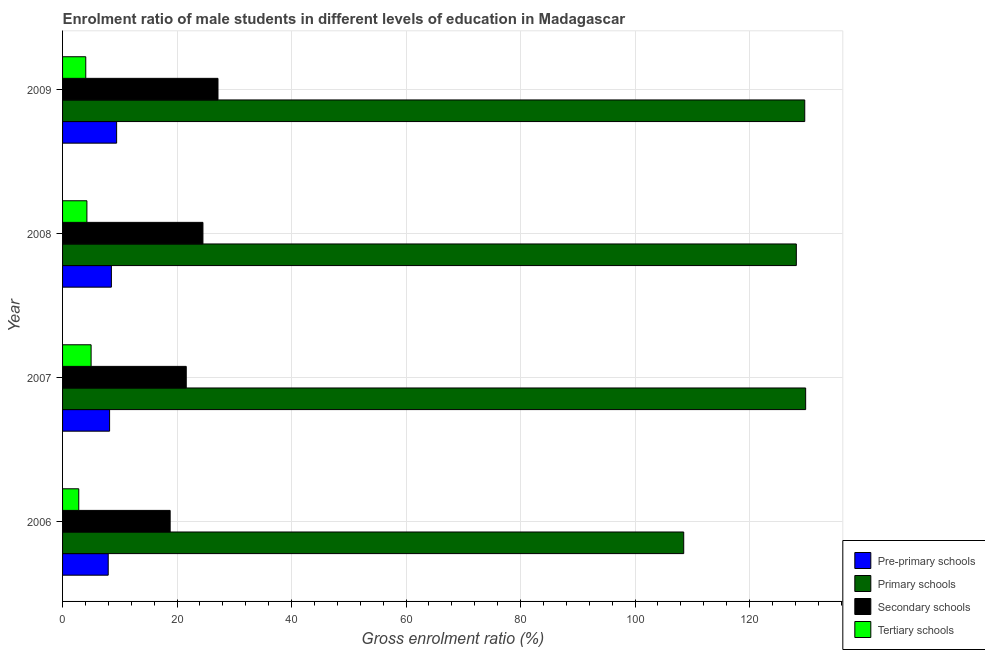Are the number of bars on each tick of the Y-axis equal?
Provide a succinct answer. Yes. How many bars are there on the 3rd tick from the top?
Your answer should be compact. 4. What is the label of the 4th group of bars from the top?
Provide a short and direct response. 2006. What is the gross enrolment ratio(female) in tertiary schools in 2007?
Give a very brief answer. 4.99. Across all years, what is the maximum gross enrolment ratio(female) in tertiary schools?
Make the answer very short. 4.99. Across all years, what is the minimum gross enrolment ratio(female) in primary schools?
Give a very brief answer. 108.5. In which year was the gross enrolment ratio(female) in pre-primary schools minimum?
Give a very brief answer. 2006. What is the total gross enrolment ratio(female) in pre-primary schools in the graph?
Make the answer very short. 34.16. What is the difference between the gross enrolment ratio(female) in tertiary schools in 2007 and that in 2009?
Keep it short and to the point. 0.93. What is the difference between the gross enrolment ratio(female) in pre-primary schools in 2007 and the gross enrolment ratio(female) in secondary schools in 2006?
Provide a succinct answer. -10.58. What is the average gross enrolment ratio(female) in pre-primary schools per year?
Give a very brief answer. 8.54. In the year 2008, what is the difference between the gross enrolment ratio(female) in primary schools and gross enrolment ratio(female) in tertiary schools?
Your response must be concise. 123.92. What is the ratio of the gross enrolment ratio(female) in tertiary schools in 2007 to that in 2008?
Ensure brevity in your answer.  1.17. Is the difference between the gross enrolment ratio(female) in secondary schools in 2006 and 2009 greater than the difference between the gross enrolment ratio(female) in primary schools in 2006 and 2009?
Offer a terse response. Yes. What is the difference between the highest and the second highest gross enrolment ratio(female) in pre-primary schools?
Your response must be concise. 0.91. What is the difference between the highest and the lowest gross enrolment ratio(female) in pre-primary schools?
Your answer should be very brief. 1.47. Is the sum of the gross enrolment ratio(female) in secondary schools in 2006 and 2008 greater than the maximum gross enrolment ratio(female) in tertiary schools across all years?
Your answer should be compact. Yes. What does the 1st bar from the top in 2007 represents?
Offer a very short reply. Tertiary schools. What does the 4th bar from the bottom in 2007 represents?
Your response must be concise. Tertiary schools. Is it the case that in every year, the sum of the gross enrolment ratio(female) in pre-primary schools and gross enrolment ratio(female) in primary schools is greater than the gross enrolment ratio(female) in secondary schools?
Provide a succinct answer. Yes. Are all the bars in the graph horizontal?
Offer a terse response. Yes. How many years are there in the graph?
Offer a terse response. 4. Are the values on the major ticks of X-axis written in scientific E-notation?
Give a very brief answer. No. Does the graph contain grids?
Your answer should be very brief. Yes. Where does the legend appear in the graph?
Offer a terse response. Bottom right. How many legend labels are there?
Your answer should be compact. 4. How are the legend labels stacked?
Offer a terse response. Vertical. What is the title of the graph?
Provide a short and direct response. Enrolment ratio of male students in different levels of education in Madagascar. What is the label or title of the X-axis?
Provide a succinct answer. Gross enrolment ratio (%). What is the Gross enrolment ratio (%) of Pre-primary schools in 2006?
Offer a very short reply. 7.97. What is the Gross enrolment ratio (%) of Primary schools in 2006?
Offer a very short reply. 108.5. What is the Gross enrolment ratio (%) in Secondary schools in 2006?
Provide a short and direct response. 18.79. What is the Gross enrolment ratio (%) of Tertiary schools in 2006?
Offer a terse response. 2.83. What is the Gross enrolment ratio (%) in Pre-primary schools in 2007?
Give a very brief answer. 8.21. What is the Gross enrolment ratio (%) in Primary schools in 2007?
Give a very brief answer. 129.8. What is the Gross enrolment ratio (%) of Secondary schools in 2007?
Offer a terse response. 21.61. What is the Gross enrolment ratio (%) of Tertiary schools in 2007?
Ensure brevity in your answer.  4.99. What is the Gross enrolment ratio (%) of Pre-primary schools in 2008?
Offer a very short reply. 8.53. What is the Gross enrolment ratio (%) of Primary schools in 2008?
Make the answer very short. 128.17. What is the Gross enrolment ratio (%) in Secondary schools in 2008?
Ensure brevity in your answer.  24.52. What is the Gross enrolment ratio (%) of Tertiary schools in 2008?
Your answer should be compact. 4.25. What is the Gross enrolment ratio (%) of Pre-primary schools in 2009?
Provide a short and direct response. 9.44. What is the Gross enrolment ratio (%) of Primary schools in 2009?
Offer a very short reply. 129.64. What is the Gross enrolment ratio (%) in Secondary schools in 2009?
Provide a short and direct response. 27.15. What is the Gross enrolment ratio (%) of Tertiary schools in 2009?
Ensure brevity in your answer.  4.05. Across all years, what is the maximum Gross enrolment ratio (%) of Pre-primary schools?
Offer a very short reply. 9.44. Across all years, what is the maximum Gross enrolment ratio (%) in Primary schools?
Provide a succinct answer. 129.8. Across all years, what is the maximum Gross enrolment ratio (%) in Secondary schools?
Your answer should be compact. 27.15. Across all years, what is the maximum Gross enrolment ratio (%) of Tertiary schools?
Your response must be concise. 4.99. Across all years, what is the minimum Gross enrolment ratio (%) in Pre-primary schools?
Your answer should be very brief. 7.97. Across all years, what is the minimum Gross enrolment ratio (%) in Primary schools?
Ensure brevity in your answer.  108.5. Across all years, what is the minimum Gross enrolment ratio (%) in Secondary schools?
Offer a terse response. 18.79. Across all years, what is the minimum Gross enrolment ratio (%) in Tertiary schools?
Your response must be concise. 2.83. What is the total Gross enrolment ratio (%) of Pre-primary schools in the graph?
Give a very brief answer. 34.16. What is the total Gross enrolment ratio (%) of Primary schools in the graph?
Offer a terse response. 496.12. What is the total Gross enrolment ratio (%) in Secondary schools in the graph?
Keep it short and to the point. 92.07. What is the total Gross enrolment ratio (%) of Tertiary schools in the graph?
Offer a very short reply. 16.12. What is the difference between the Gross enrolment ratio (%) in Pre-primary schools in 2006 and that in 2007?
Provide a succinct answer. -0.24. What is the difference between the Gross enrolment ratio (%) of Primary schools in 2006 and that in 2007?
Provide a succinct answer. -21.3. What is the difference between the Gross enrolment ratio (%) in Secondary schools in 2006 and that in 2007?
Your answer should be very brief. -2.81. What is the difference between the Gross enrolment ratio (%) of Tertiary schools in 2006 and that in 2007?
Provide a short and direct response. -2.16. What is the difference between the Gross enrolment ratio (%) in Pre-primary schools in 2006 and that in 2008?
Offer a very short reply. -0.55. What is the difference between the Gross enrolment ratio (%) in Primary schools in 2006 and that in 2008?
Offer a terse response. -19.67. What is the difference between the Gross enrolment ratio (%) of Secondary schools in 2006 and that in 2008?
Keep it short and to the point. -5.73. What is the difference between the Gross enrolment ratio (%) in Tertiary schools in 2006 and that in 2008?
Make the answer very short. -1.42. What is the difference between the Gross enrolment ratio (%) of Pre-primary schools in 2006 and that in 2009?
Give a very brief answer. -1.47. What is the difference between the Gross enrolment ratio (%) in Primary schools in 2006 and that in 2009?
Provide a short and direct response. -21.14. What is the difference between the Gross enrolment ratio (%) of Secondary schools in 2006 and that in 2009?
Ensure brevity in your answer.  -8.36. What is the difference between the Gross enrolment ratio (%) of Tertiary schools in 2006 and that in 2009?
Ensure brevity in your answer.  -1.22. What is the difference between the Gross enrolment ratio (%) in Pre-primary schools in 2007 and that in 2008?
Give a very brief answer. -0.31. What is the difference between the Gross enrolment ratio (%) in Primary schools in 2007 and that in 2008?
Keep it short and to the point. 1.63. What is the difference between the Gross enrolment ratio (%) of Secondary schools in 2007 and that in 2008?
Your response must be concise. -2.91. What is the difference between the Gross enrolment ratio (%) in Tertiary schools in 2007 and that in 2008?
Ensure brevity in your answer.  0.73. What is the difference between the Gross enrolment ratio (%) in Pre-primary schools in 2007 and that in 2009?
Your answer should be compact. -1.23. What is the difference between the Gross enrolment ratio (%) in Primary schools in 2007 and that in 2009?
Provide a short and direct response. 0.16. What is the difference between the Gross enrolment ratio (%) of Secondary schools in 2007 and that in 2009?
Ensure brevity in your answer.  -5.54. What is the difference between the Gross enrolment ratio (%) of Tertiary schools in 2007 and that in 2009?
Keep it short and to the point. 0.93. What is the difference between the Gross enrolment ratio (%) of Pre-primary schools in 2008 and that in 2009?
Give a very brief answer. -0.91. What is the difference between the Gross enrolment ratio (%) of Primary schools in 2008 and that in 2009?
Offer a terse response. -1.47. What is the difference between the Gross enrolment ratio (%) of Secondary schools in 2008 and that in 2009?
Provide a short and direct response. -2.63. What is the difference between the Gross enrolment ratio (%) of Tertiary schools in 2008 and that in 2009?
Provide a succinct answer. 0.2. What is the difference between the Gross enrolment ratio (%) in Pre-primary schools in 2006 and the Gross enrolment ratio (%) in Primary schools in 2007?
Make the answer very short. -121.83. What is the difference between the Gross enrolment ratio (%) of Pre-primary schools in 2006 and the Gross enrolment ratio (%) of Secondary schools in 2007?
Give a very brief answer. -13.63. What is the difference between the Gross enrolment ratio (%) in Pre-primary schools in 2006 and the Gross enrolment ratio (%) in Tertiary schools in 2007?
Offer a terse response. 2.99. What is the difference between the Gross enrolment ratio (%) of Primary schools in 2006 and the Gross enrolment ratio (%) of Secondary schools in 2007?
Ensure brevity in your answer.  86.9. What is the difference between the Gross enrolment ratio (%) in Primary schools in 2006 and the Gross enrolment ratio (%) in Tertiary schools in 2007?
Keep it short and to the point. 103.52. What is the difference between the Gross enrolment ratio (%) in Secondary schools in 2006 and the Gross enrolment ratio (%) in Tertiary schools in 2007?
Your answer should be very brief. 13.81. What is the difference between the Gross enrolment ratio (%) of Pre-primary schools in 2006 and the Gross enrolment ratio (%) of Primary schools in 2008?
Ensure brevity in your answer.  -120.2. What is the difference between the Gross enrolment ratio (%) of Pre-primary schools in 2006 and the Gross enrolment ratio (%) of Secondary schools in 2008?
Your answer should be very brief. -16.55. What is the difference between the Gross enrolment ratio (%) in Pre-primary schools in 2006 and the Gross enrolment ratio (%) in Tertiary schools in 2008?
Your response must be concise. 3.72. What is the difference between the Gross enrolment ratio (%) in Primary schools in 2006 and the Gross enrolment ratio (%) in Secondary schools in 2008?
Ensure brevity in your answer.  83.98. What is the difference between the Gross enrolment ratio (%) in Primary schools in 2006 and the Gross enrolment ratio (%) in Tertiary schools in 2008?
Ensure brevity in your answer.  104.25. What is the difference between the Gross enrolment ratio (%) of Secondary schools in 2006 and the Gross enrolment ratio (%) of Tertiary schools in 2008?
Ensure brevity in your answer.  14.54. What is the difference between the Gross enrolment ratio (%) in Pre-primary schools in 2006 and the Gross enrolment ratio (%) in Primary schools in 2009?
Make the answer very short. -121.67. What is the difference between the Gross enrolment ratio (%) of Pre-primary schools in 2006 and the Gross enrolment ratio (%) of Secondary schools in 2009?
Make the answer very short. -19.17. What is the difference between the Gross enrolment ratio (%) in Pre-primary schools in 2006 and the Gross enrolment ratio (%) in Tertiary schools in 2009?
Your answer should be very brief. 3.92. What is the difference between the Gross enrolment ratio (%) of Primary schools in 2006 and the Gross enrolment ratio (%) of Secondary schools in 2009?
Offer a terse response. 81.35. What is the difference between the Gross enrolment ratio (%) of Primary schools in 2006 and the Gross enrolment ratio (%) of Tertiary schools in 2009?
Provide a short and direct response. 104.45. What is the difference between the Gross enrolment ratio (%) in Secondary schools in 2006 and the Gross enrolment ratio (%) in Tertiary schools in 2009?
Your answer should be very brief. 14.74. What is the difference between the Gross enrolment ratio (%) in Pre-primary schools in 2007 and the Gross enrolment ratio (%) in Primary schools in 2008?
Your answer should be very brief. -119.96. What is the difference between the Gross enrolment ratio (%) of Pre-primary schools in 2007 and the Gross enrolment ratio (%) of Secondary schools in 2008?
Make the answer very short. -16.31. What is the difference between the Gross enrolment ratio (%) of Pre-primary schools in 2007 and the Gross enrolment ratio (%) of Tertiary schools in 2008?
Offer a very short reply. 3.96. What is the difference between the Gross enrolment ratio (%) in Primary schools in 2007 and the Gross enrolment ratio (%) in Secondary schools in 2008?
Provide a short and direct response. 105.28. What is the difference between the Gross enrolment ratio (%) of Primary schools in 2007 and the Gross enrolment ratio (%) of Tertiary schools in 2008?
Your answer should be very brief. 125.55. What is the difference between the Gross enrolment ratio (%) of Secondary schools in 2007 and the Gross enrolment ratio (%) of Tertiary schools in 2008?
Your answer should be compact. 17.35. What is the difference between the Gross enrolment ratio (%) of Pre-primary schools in 2007 and the Gross enrolment ratio (%) of Primary schools in 2009?
Provide a succinct answer. -121.43. What is the difference between the Gross enrolment ratio (%) in Pre-primary schools in 2007 and the Gross enrolment ratio (%) in Secondary schools in 2009?
Your response must be concise. -18.93. What is the difference between the Gross enrolment ratio (%) in Pre-primary schools in 2007 and the Gross enrolment ratio (%) in Tertiary schools in 2009?
Provide a succinct answer. 4.16. What is the difference between the Gross enrolment ratio (%) of Primary schools in 2007 and the Gross enrolment ratio (%) of Secondary schools in 2009?
Keep it short and to the point. 102.65. What is the difference between the Gross enrolment ratio (%) of Primary schools in 2007 and the Gross enrolment ratio (%) of Tertiary schools in 2009?
Your answer should be compact. 125.75. What is the difference between the Gross enrolment ratio (%) in Secondary schools in 2007 and the Gross enrolment ratio (%) in Tertiary schools in 2009?
Keep it short and to the point. 17.55. What is the difference between the Gross enrolment ratio (%) of Pre-primary schools in 2008 and the Gross enrolment ratio (%) of Primary schools in 2009?
Your response must be concise. -121.11. What is the difference between the Gross enrolment ratio (%) of Pre-primary schools in 2008 and the Gross enrolment ratio (%) of Secondary schools in 2009?
Your answer should be very brief. -18.62. What is the difference between the Gross enrolment ratio (%) of Pre-primary schools in 2008 and the Gross enrolment ratio (%) of Tertiary schools in 2009?
Your response must be concise. 4.47. What is the difference between the Gross enrolment ratio (%) in Primary schools in 2008 and the Gross enrolment ratio (%) in Secondary schools in 2009?
Your response must be concise. 101.02. What is the difference between the Gross enrolment ratio (%) in Primary schools in 2008 and the Gross enrolment ratio (%) in Tertiary schools in 2009?
Keep it short and to the point. 124.12. What is the difference between the Gross enrolment ratio (%) of Secondary schools in 2008 and the Gross enrolment ratio (%) of Tertiary schools in 2009?
Ensure brevity in your answer.  20.47. What is the average Gross enrolment ratio (%) of Pre-primary schools per year?
Ensure brevity in your answer.  8.54. What is the average Gross enrolment ratio (%) of Primary schools per year?
Provide a succinct answer. 124.03. What is the average Gross enrolment ratio (%) in Secondary schools per year?
Ensure brevity in your answer.  23.02. What is the average Gross enrolment ratio (%) of Tertiary schools per year?
Keep it short and to the point. 4.03. In the year 2006, what is the difference between the Gross enrolment ratio (%) of Pre-primary schools and Gross enrolment ratio (%) of Primary schools?
Keep it short and to the point. -100.53. In the year 2006, what is the difference between the Gross enrolment ratio (%) of Pre-primary schools and Gross enrolment ratio (%) of Secondary schools?
Your response must be concise. -10.82. In the year 2006, what is the difference between the Gross enrolment ratio (%) of Pre-primary schools and Gross enrolment ratio (%) of Tertiary schools?
Keep it short and to the point. 5.14. In the year 2006, what is the difference between the Gross enrolment ratio (%) of Primary schools and Gross enrolment ratio (%) of Secondary schools?
Make the answer very short. 89.71. In the year 2006, what is the difference between the Gross enrolment ratio (%) of Primary schools and Gross enrolment ratio (%) of Tertiary schools?
Offer a very short reply. 105.67. In the year 2006, what is the difference between the Gross enrolment ratio (%) in Secondary schools and Gross enrolment ratio (%) in Tertiary schools?
Your answer should be very brief. 15.96. In the year 2007, what is the difference between the Gross enrolment ratio (%) of Pre-primary schools and Gross enrolment ratio (%) of Primary schools?
Offer a very short reply. -121.59. In the year 2007, what is the difference between the Gross enrolment ratio (%) in Pre-primary schools and Gross enrolment ratio (%) in Secondary schools?
Provide a short and direct response. -13.39. In the year 2007, what is the difference between the Gross enrolment ratio (%) of Pre-primary schools and Gross enrolment ratio (%) of Tertiary schools?
Offer a terse response. 3.23. In the year 2007, what is the difference between the Gross enrolment ratio (%) in Primary schools and Gross enrolment ratio (%) in Secondary schools?
Provide a short and direct response. 108.19. In the year 2007, what is the difference between the Gross enrolment ratio (%) in Primary schools and Gross enrolment ratio (%) in Tertiary schools?
Give a very brief answer. 124.81. In the year 2007, what is the difference between the Gross enrolment ratio (%) in Secondary schools and Gross enrolment ratio (%) in Tertiary schools?
Offer a terse response. 16.62. In the year 2008, what is the difference between the Gross enrolment ratio (%) in Pre-primary schools and Gross enrolment ratio (%) in Primary schools?
Your answer should be compact. -119.64. In the year 2008, what is the difference between the Gross enrolment ratio (%) of Pre-primary schools and Gross enrolment ratio (%) of Secondary schools?
Provide a succinct answer. -15.99. In the year 2008, what is the difference between the Gross enrolment ratio (%) of Pre-primary schools and Gross enrolment ratio (%) of Tertiary schools?
Keep it short and to the point. 4.28. In the year 2008, what is the difference between the Gross enrolment ratio (%) in Primary schools and Gross enrolment ratio (%) in Secondary schools?
Offer a terse response. 103.65. In the year 2008, what is the difference between the Gross enrolment ratio (%) of Primary schools and Gross enrolment ratio (%) of Tertiary schools?
Give a very brief answer. 123.92. In the year 2008, what is the difference between the Gross enrolment ratio (%) of Secondary schools and Gross enrolment ratio (%) of Tertiary schools?
Give a very brief answer. 20.27. In the year 2009, what is the difference between the Gross enrolment ratio (%) of Pre-primary schools and Gross enrolment ratio (%) of Primary schools?
Your response must be concise. -120.2. In the year 2009, what is the difference between the Gross enrolment ratio (%) of Pre-primary schools and Gross enrolment ratio (%) of Secondary schools?
Offer a terse response. -17.71. In the year 2009, what is the difference between the Gross enrolment ratio (%) of Pre-primary schools and Gross enrolment ratio (%) of Tertiary schools?
Your answer should be compact. 5.39. In the year 2009, what is the difference between the Gross enrolment ratio (%) of Primary schools and Gross enrolment ratio (%) of Secondary schools?
Provide a succinct answer. 102.49. In the year 2009, what is the difference between the Gross enrolment ratio (%) of Primary schools and Gross enrolment ratio (%) of Tertiary schools?
Your answer should be compact. 125.59. In the year 2009, what is the difference between the Gross enrolment ratio (%) of Secondary schools and Gross enrolment ratio (%) of Tertiary schools?
Provide a short and direct response. 23.09. What is the ratio of the Gross enrolment ratio (%) in Pre-primary schools in 2006 to that in 2007?
Your answer should be compact. 0.97. What is the ratio of the Gross enrolment ratio (%) in Primary schools in 2006 to that in 2007?
Ensure brevity in your answer.  0.84. What is the ratio of the Gross enrolment ratio (%) in Secondary schools in 2006 to that in 2007?
Offer a very short reply. 0.87. What is the ratio of the Gross enrolment ratio (%) in Tertiary schools in 2006 to that in 2007?
Your answer should be very brief. 0.57. What is the ratio of the Gross enrolment ratio (%) in Pre-primary schools in 2006 to that in 2008?
Your answer should be compact. 0.94. What is the ratio of the Gross enrolment ratio (%) of Primary schools in 2006 to that in 2008?
Your answer should be very brief. 0.85. What is the ratio of the Gross enrolment ratio (%) in Secondary schools in 2006 to that in 2008?
Your response must be concise. 0.77. What is the ratio of the Gross enrolment ratio (%) in Tertiary schools in 2006 to that in 2008?
Your answer should be very brief. 0.67. What is the ratio of the Gross enrolment ratio (%) of Pre-primary schools in 2006 to that in 2009?
Provide a short and direct response. 0.84. What is the ratio of the Gross enrolment ratio (%) in Primary schools in 2006 to that in 2009?
Your response must be concise. 0.84. What is the ratio of the Gross enrolment ratio (%) of Secondary schools in 2006 to that in 2009?
Offer a very short reply. 0.69. What is the ratio of the Gross enrolment ratio (%) of Tertiary schools in 2006 to that in 2009?
Provide a succinct answer. 0.7. What is the ratio of the Gross enrolment ratio (%) of Pre-primary schools in 2007 to that in 2008?
Offer a very short reply. 0.96. What is the ratio of the Gross enrolment ratio (%) in Primary schools in 2007 to that in 2008?
Your response must be concise. 1.01. What is the ratio of the Gross enrolment ratio (%) of Secondary schools in 2007 to that in 2008?
Keep it short and to the point. 0.88. What is the ratio of the Gross enrolment ratio (%) in Tertiary schools in 2007 to that in 2008?
Give a very brief answer. 1.17. What is the ratio of the Gross enrolment ratio (%) of Pre-primary schools in 2007 to that in 2009?
Offer a very short reply. 0.87. What is the ratio of the Gross enrolment ratio (%) of Secondary schools in 2007 to that in 2009?
Your response must be concise. 0.8. What is the ratio of the Gross enrolment ratio (%) of Tertiary schools in 2007 to that in 2009?
Make the answer very short. 1.23. What is the ratio of the Gross enrolment ratio (%) of Pre-primary schools in 2008 to that in 2009?
Keep it short and to the point. 0.9. What is the ratio of the Gross enrolment ratio (%) of Primary schools in 2008 to that in 2009?
Offer a terse response. 0.99. What is the ratio of the Gross enrolment ratio (%) in Secondary schools in 2008 to that in 2009?
Your response must be concise. 0.9. What is the ratio of the Gross enrolment ratio (%) in Tertiary schools in 2008 to that in 2009?
Provide a succinct answer. 1.05. What is the difference between the highest and the second highest Gross enrolment ratio (%) of Pre-primary schools?
Your answer should be compact. 0.91. What is the difference between the highest and the second highest Gross enrolment ratio (%) of Primary schools?
Your response must be concise. 0.16. What is the difference between the highest and the second highest Gross enrolment ratio (%) of Secondary schools?
Offer a very short reply. 2.63. What is the difference between the highest and the second highest Gross enrolment ratio (%) of Tertiary schools?
Give a very brief answer. 0.73. What is the difference between the highest and the lowest Gross enrolment ratio (%) of Pre-primary schools?
Your response must be concise. 1.47. What is the difference between the highest and the lowest Gross enrolment ratio (%) in Primary schools?
Your answer should be very brief. 21.3. What is the difference between the highest and the lowest Gross enrolment ratio (%) of Secondary schools?
Offer a very short reply. 8.36. What is the difference between the highest and the lowest Gross enrolment ratio (%) of Tertiary schools?
Provide a succinct answer. 2.16. 